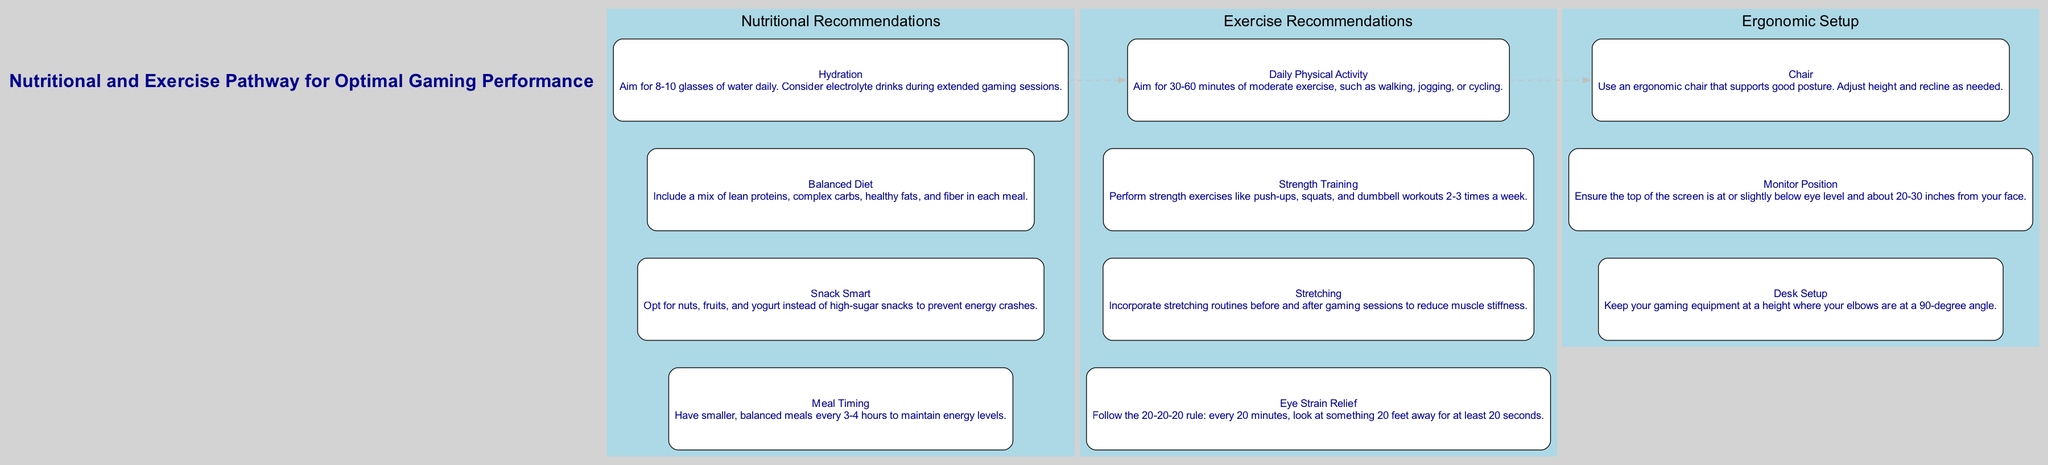What are the four main categories in the diagram? The diagram contains three primary categories: Nutritional Recommendations, Exercise Recommendations, and Ergonomic Setup. Each category has its own set of components.
Answer: Nutritional Recommendations, Exercise Recommendations, Ergonomic Setup How many components are there in the Nutritional Recommendations category? In the Nutritional Recommendations category, there are four components: Hydration, Balanced Diet, Snack Smart, and Meal Timing.
Answer: 4 Which snack option is recommended for preventing energy crashes? The diagram suggests opting for nuts, fruits, and yogurt instead of high-sugar snacks to prevent energy crashes.
Answer: Nuts, fruits, yogurt What does the 20-20-20 rule help with? The 20-20-20 rule is a guideline to relieve eye strain by promoting regular breaks from screens to look at distant objects.
Answer: Eye strain relief What is the recommended duration of daily physical activity? The diagram advises aiming for 30-60 minutes of moderate exercise daily.
Answer: 30-60 minutes How should gaming equipment be positioned according to the Ergonomic Setup? The diagram states that gaming equipment should be positioned so that the elbows are at a 90-degree angle.
Answer: 90-degree angle What should be done before and after gaming sessions to reduce muscle stiffness? The diagram emphasizes the importance of incorporating stretching routines before and after gaming sessions.
Answer: Stretching routines How many times a week should strength training be performed? The recommended frequency for strength training according to the diagram is 2-3 times a week.
Answer: 2-3 times a week What’s the purpose of hydration recommendations during gaming? The diagram recommends hydration to ensure adequate fluid intake, with an emphasis on electrolyte drinks during extended gaming sessions.
Answer: Adequate fluid intake 